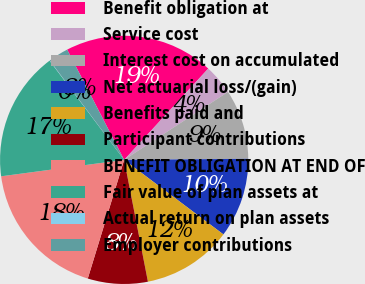Convert chart to OTSL. <chart><loc_0><loc_0><loc_500><loc_500><pie_chart><fcel>Benefit obligation at<fcel>Service cost<fcel>Interest cost on accumulated<fcel>Net actuarial loss/(gain)<fcel>Benefits paid and<fcel>Participant contributions<fcel>BENEFIT OBLIGATION AT END OF<fcel>Fair value of plan assets at<fcel>Actual return on plan assets<fcel>Employer contributions<nl><fcel>19.44%<fcel>3.92%<fcel>9.09%<fcel>10.39%<fcel>11.68%<fcel>7.8%<fcel>18.15%<fcel>16.85%<fcel>0.04%<fcel>2.63%<nl></chart> 